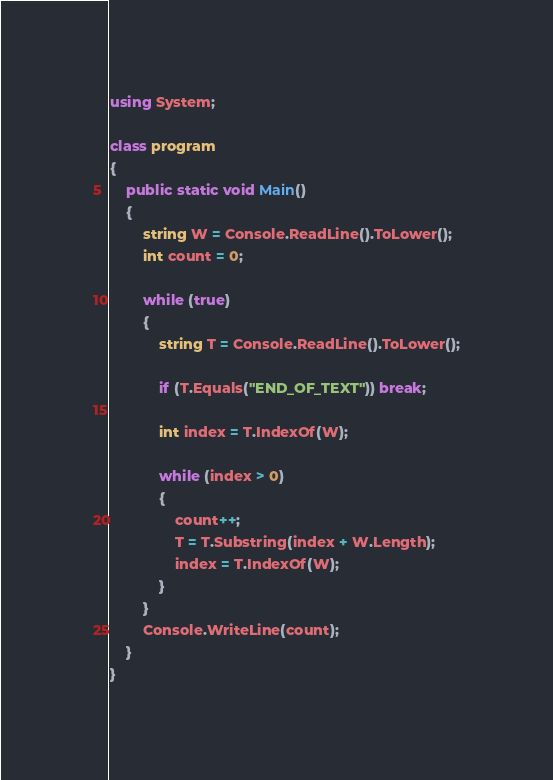<code> <loc_0><loc_0><loc_500><loc_500><_C#_>using System;

class program
{
    public static void Main()
    {
        string W = Console.ReadLine().ToLower();
        int count = 0;

        while (true)
        {
            string T = Console.ReadLine().ToLower();

            if (T.Equals("END_OF_TEXT")) break;

            int index = T.IndexOf(W);

            while (index > 0)
            {
                count++;
                T = T.Substring(index + W.Length);
                index = T.IndexOf(W);
            }
        }
        Console.WriteLine(count);
    }
}</code> 